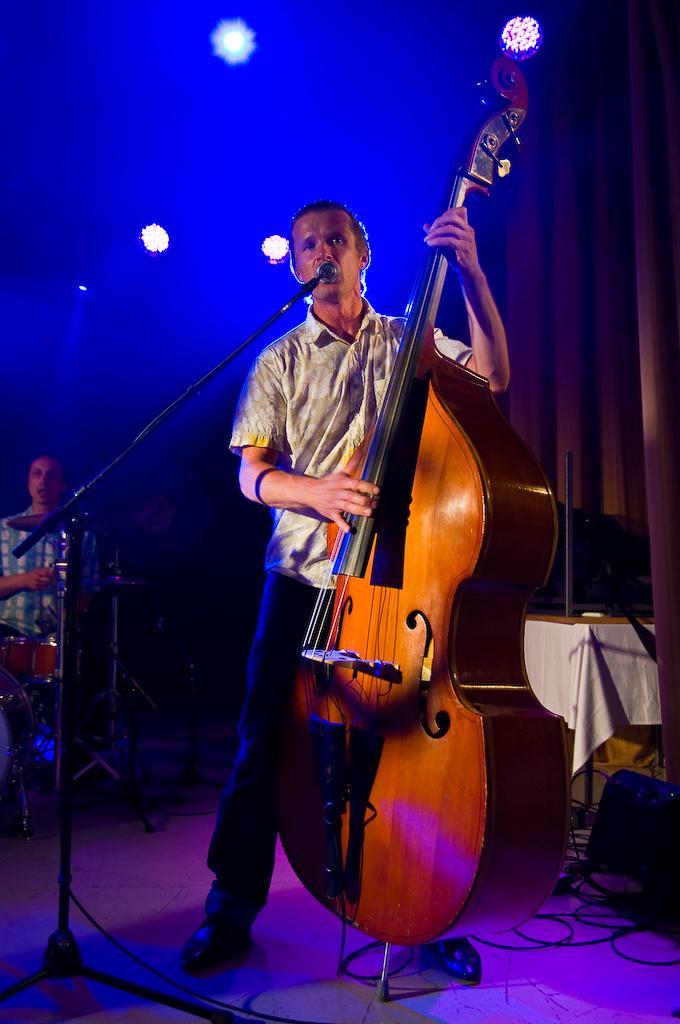Please provide a concise description of this image. In the picture we can see a man standing and singing a song in the microphone and playing a musical instrument, behind him we can see another man playing a musical instrument. In the background, we can see some lights. 